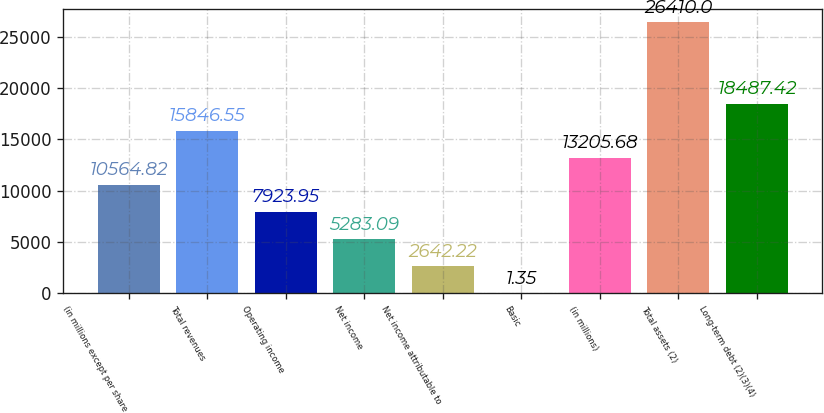Convert chart. <chart><loc_0><loc_0><loc_500><loc_500><bar_chart><fcel>(in millions except per share<fcel>Total revenues<fcel>Operating income<fcel>Net income<fcel>Net income attributable to<fcel>Basic<fcel>(in millions)<fcel>Total assets (2)<fcel>Long-term debt (2)(3)(4)<nl><fcel>10564.8<fcel>15846.5<fcel>7923.95<fcel>5283.09<fcel>2642.22<fcel>1.35<fcel>13205.7<fcel>26410<fcel>18487.4<nl></chart> 